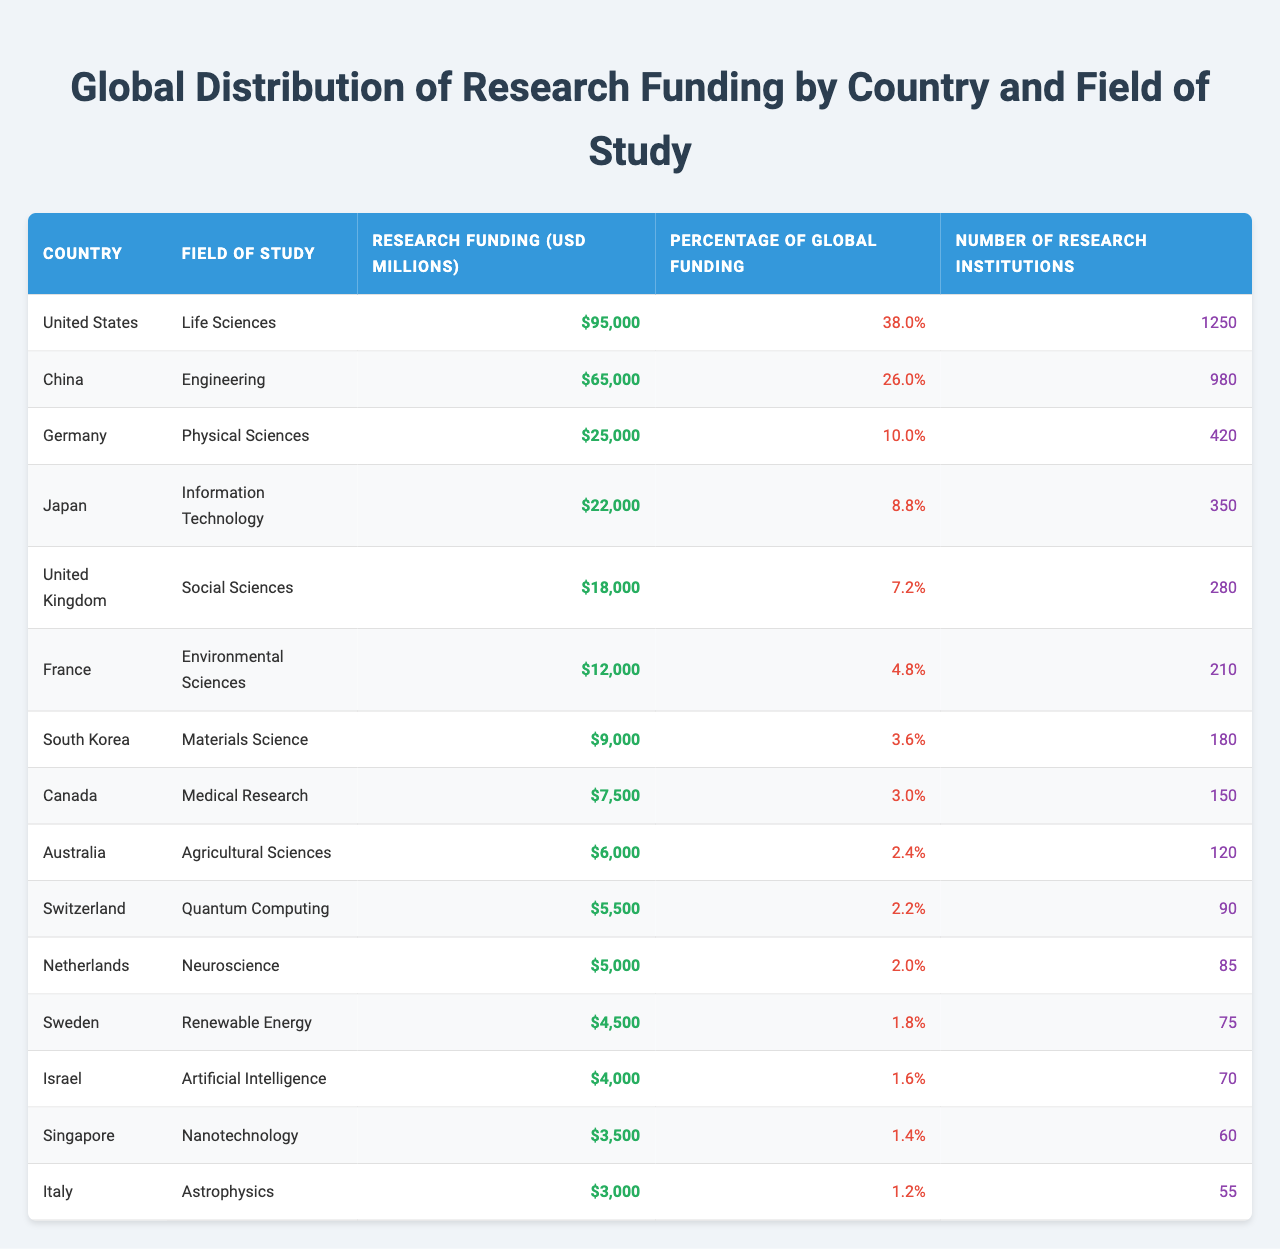What country has the highest research funding in Life Sciences? The table shows that the United States has the highest research funding in Life Sciences at 95,000 million USD.
Answer: United States What percentage of global funding is attributed to Germany's research in Physical Sciences? According to the table, Germany's research in Physical Sciences accounts for 10.0% of global funding.
Answer: 10.0% How much research funding does China allocate to Engineering compared to the United Kingdom’s funding in Social Sciences? China allocates 65,000 million USD for Engineering, while the UK allocates 18,000 million USD for Social Sciences. The difference is 65,000 - 18,000 = 47,000 million USD more for China.
Answer: 47,000 million USD Is the research funding for Australia in Agricultural Sciences greater than that for Switzerland in Quantum Computing? The table indicates Australia received 6,000 million USD while Switzerland received 5,500 million USD, confirming that Australia has more funding.
Answer: Yes What is the total number of research institutions for the top three countries by funding? The United States has 1,250 institutions, China has 980, and Germany has 420. Adding these gives: 1,250 + 980 + 420 = 2,650 institutions.
Answer: 2,650 Which country has the lowest research funding and what is the amount? The table reveals that Italy has the lowest research funding in Astrophysics at 3,000 million USD.
Answer: Italy, 3,000 million USD If we consider the top five countries by research funding, what is the average funding amount? The top five countries by funding are the United States (95,000), China (65,000), Germany (25,000), Japan (22,000), and the United Kingdom (18,000). The total for these is 95,000 + 65,000 + 25,000 + 22,000 + 18,000 = 225,000 million USD, and the average is 225,000 / 5 = 45,000 million USD.
Answer: 45,000 million USD Are there more research institutions in South Korea for Materials Science compared to Canada’s Medical Research institutions? The table shows South Korea has 180 institutions while Canada has 150 institutions, indicating South Korea has more.
Answer: Yes Which field of study has the third highest funding and what is the corresponding percentage of global funding? The third highest funding is for Physical Sciences in Germany, with a funding amount of 25,000 million USD, representing 10.0% of global funding.
Answer: Physical Sciences, 10.0% What is the total research funding for Environmental Sciences and Agricultural Sciences combined? Environmental Sciences (France) has 12,000 million USD and Agricultural Sciences (Australia) has 6,000 million USD. Adding them gives: 12,000 + 6,000 = 18,000 million USD.
Answer: 18,000 million USD 